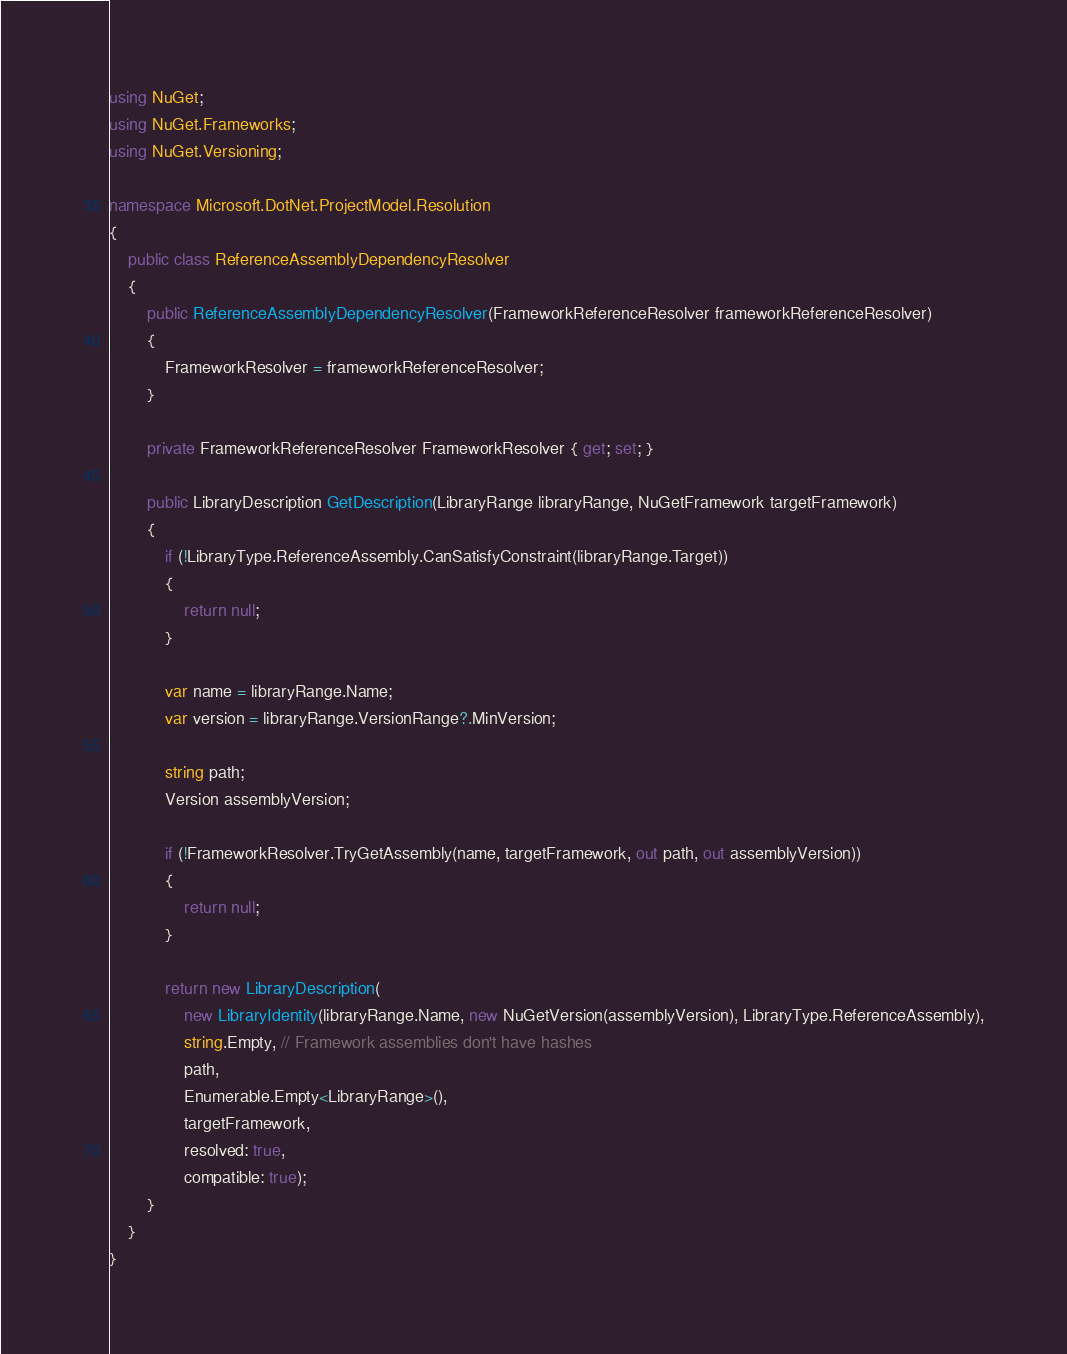<code> <loc_0><loc_0><loc_500><loc_500><_C#_>using NuGet;
using NuGet.Frameworks;
using NuGet.Versioning;

namespace Microsoft.DotNet.ProjectModel.Resolution
{
    public class ReferenceAssemblyDependencyResolver
    {
        public ReferenceAssemblyDependencyResolver(FrameworkReferenceResolver frameworkReferenceResolver)
        {
            FrameworkResolver = frameworkReferenceResolver;
        }

        private FrameworkReferenceResolver FrameworkResolver { get; set; }

        public LibraryDescription GetDescription(LibraryRange libraryRange, NuGetFramework targetFramework)
        {
            if (!LibraryType.ReferenceAssembly.CanSatisfyConstraint(libraryRange.Target))
            {
                return null;
            }

            var name = libraryRange.Name;
            var version = libraryRange.VersionRange?.MinVersion;

            string path;
            Version assemblyVersion;

            if (!FrameworkResolver.TryGetAssembly(name, targetFramework, out path, out assemblyVersion))
            {
                return null;
            }

            return new LibraryDescription(
                new LibraryIdentity(libraryRange.Name, new NuGetVersion(assemblyVersion), LibraryType.ReferenceAssembly),
                string.Empty, // Framework assemblies don't have hashes
                path,
                Enumerable.Empty<LibraryRange>(),
                targetFramework,
                resolved: true,
                compatible: true);
        }
    }
}
</code> 